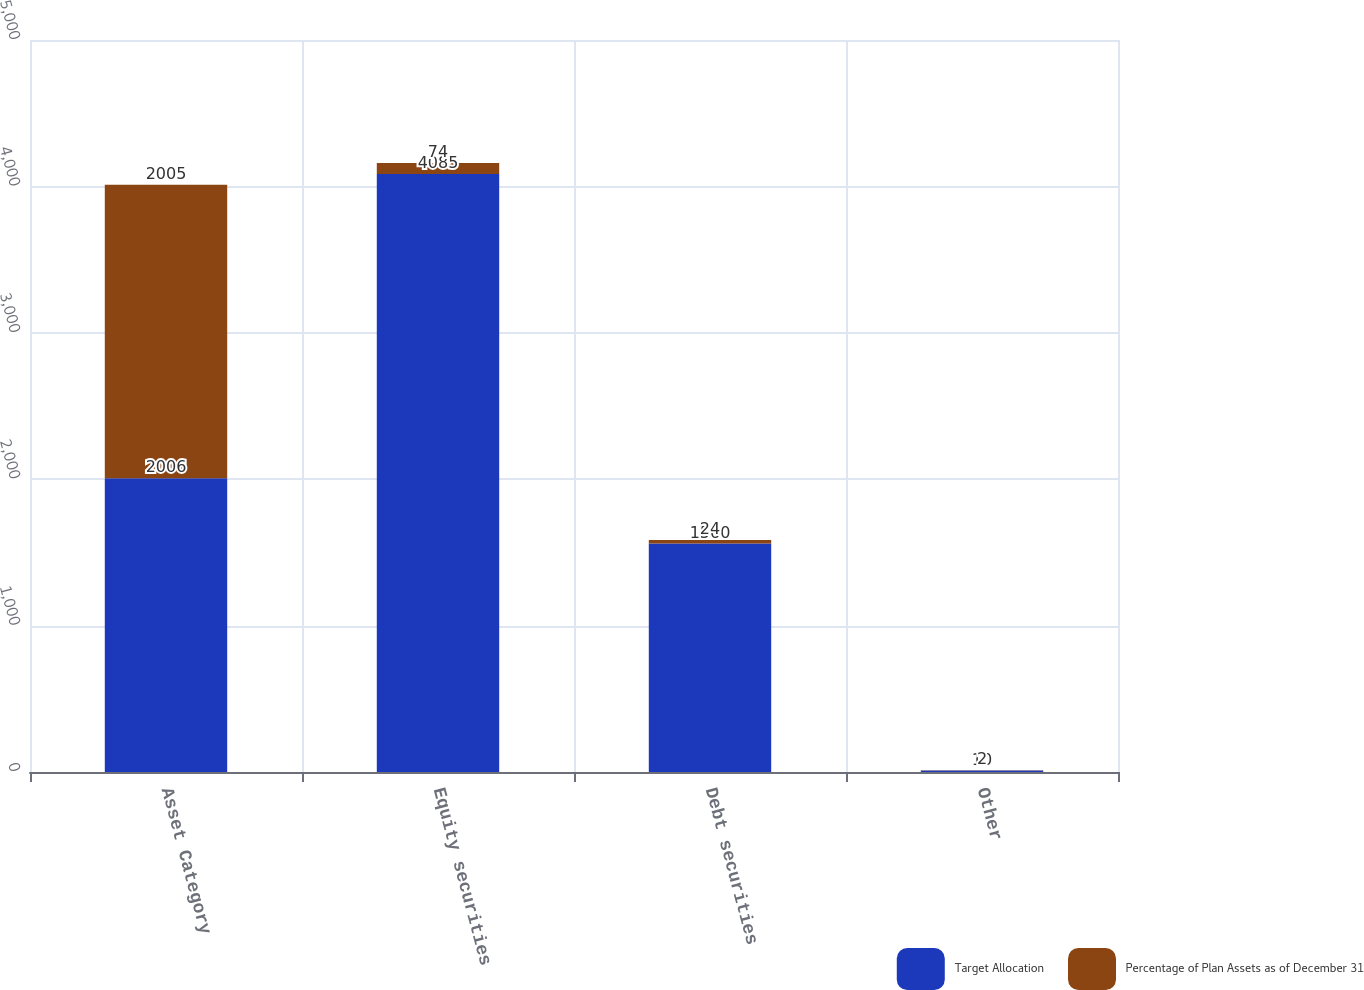<chart> <loc_0><loc_0><loc_500><loc_500><stacked_bar_chart><ecel><fcel>Asset Category<fcel>Equity securities<fcel>Debt securities<fcel>Other<nl><fcel>Target Allocation<fcel>2006<fcel>4085<fcel>1560<fcel>10<nl><fcel>Percentage of Plan Assets as of December 31<fcel>2005<fcel>74<fcel>24<fcel>2<nl></chart> 